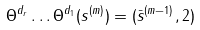Convert formula to latex. <formula><loc_0><loc_0><loc_500><loc_500>\Theta ^ { d _ { r } } \dots \Theta ^ { d _ { 1 } } ( s ^ { ( m ) } ) = ( \bar { s } ^ { ( m - 1 ) } , 2 )</formula> 